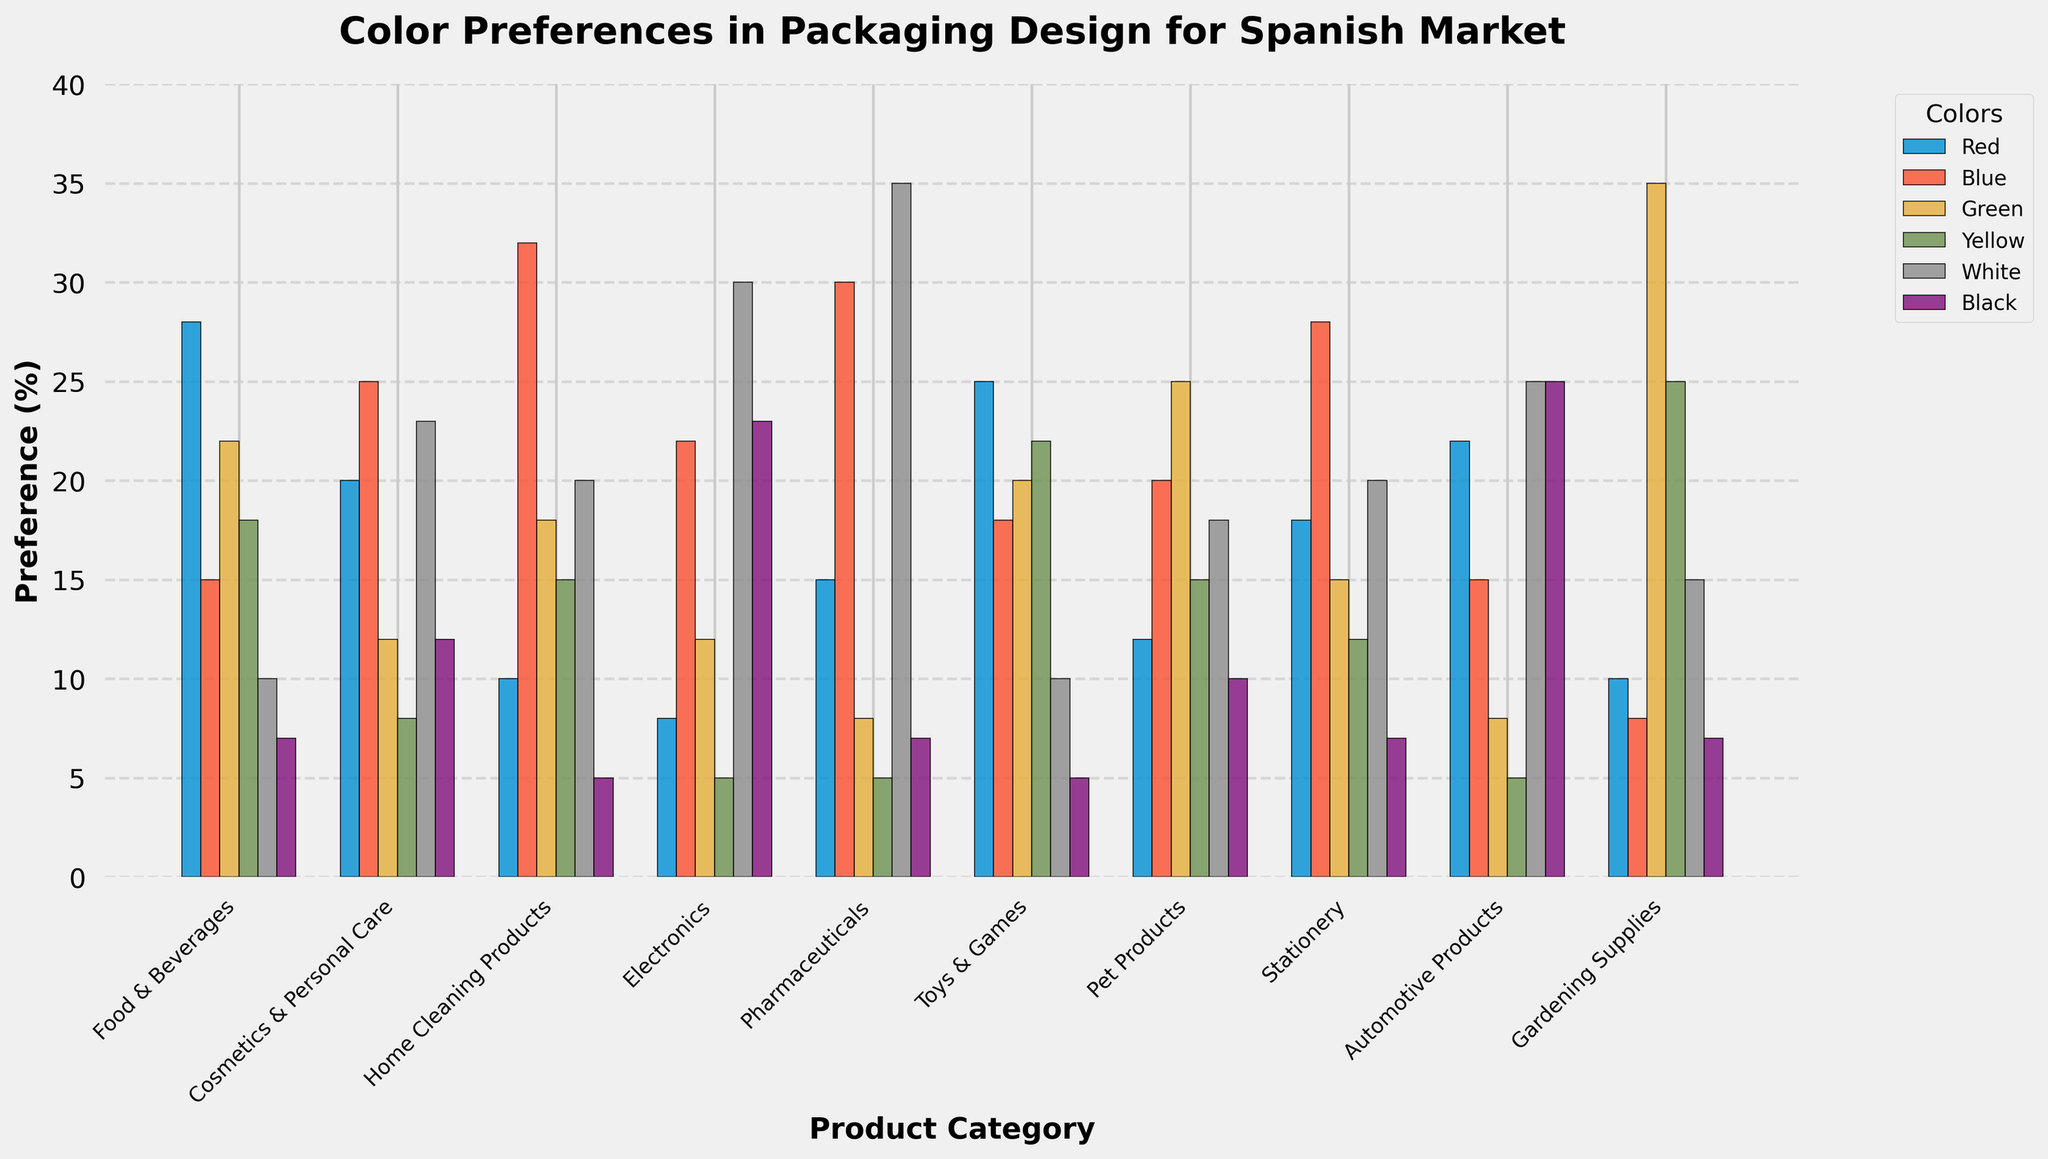What is the most preferred color for packaging in the "Cosmetics & Personal Care" category? In the "Cosmetics & Personal Care" category, the color with the highest bar is Blue.
Answer: Blue Which product category shows the least preference for the color Red? By comparing the heights of the Red bars across all categories, "Electronics" has the shortest bar for Red.
Answer: Electronics What is the difference in preference percentage between the most preferred and least preferred color for "Food & Beverages"? For "Food & Beverages", the most preferred color is Red (28%) and the least preferred is Black (7%). The difference is 28 - 7 = 21%.
Answer: 21% Which product category has the highest preference for Yellow packaging? Comparing the height of the Yellow bars across all categories, "Gardening Supplies" shows the highest preference for Yellow with a value of 25.
Answer: Gardening Supplies Is White or Black more preferred for "Pharmaceuticals"? By how much? For "Pharmaceuticals", White has a preference of 35% while Black has 7%. White is more preferred by 35 - 7 = 28%.
Answer: White, 28% How does the preference for Blue in "Home Cleaning Products" compare to that in "Pet Products"? The preference for Blue in "Home Cleaning Products" is 32% while in "Pet Products" it is 20%. "Home Cleaning Products" has a higher preference for Blue by 32 - 20 = 12%.
Answer: Home Cleaning Products, 12% What is the average preference for Black packaging across all product categories? To find the average, sum the preferences for Black across all categories (7+12+5+23+7+5+10+7+25+7) which equals 108, and divide by the number of categories which is 10. The average is 108/10 = 10.8%.
Answer: 10.8% Which color is the least preferred for "Stationery"? In the "Stationery" category, the color with the shortest bar is Yellow.
Answer: Yellow In the "Automotive Products" category, how does the preference for Green compare to that for Red? For "Automotive Products", Green has a preference of 8% and Red has 22%. Red is preferred by 22 - 8 = 14% more.
Answer: Red, 14% Does "Toys & Games" have a higher preference for Green or Red? In "Toys & Games", the preference for Green is 20% and for Red is 25%. Red is preferred more.
Answer: Red 